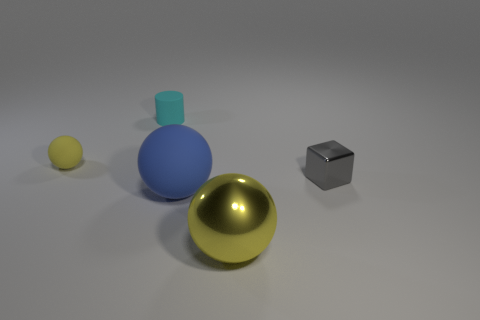What color is the sphere on the left side of the small rubber object right of the yellow object to the left of the large shiny thing?
Provide a short and direct response. Yellow. What number of large yellow metal things are to the right of the large thing behind the big yellow metallic ball?
Your answer should be very brief. 1. How many other objects are there of the same shape as the large matte thing?
Provide a succinct answer. 2. How many things are either large red blocks or balls left of the large yellow metal ball?
Your response must be concise. 2. Is the number of rubber spheres behind the small metal object greater than the number of yellow matte balls that are right of the large metal thing?
Provide a short and direct response. Yes. What is the shape of the shiny object in front of the tiny object that is in front of the yellow sphere that is behind the small gray block?
Your answer should be compact. Sphere. There is a yellow object on the right side of the yellow thing that is behind the large rubber object; what shape is it?
Offer a very short reply. Sphere. Is there a yellow ball made of the same material as the tiny gray block?
Make the answer very short. Yes. The other metallic sphere that is the same color as the small sphere is what size?
Keep it short and to the point. Large. How many red things are either tiny balls or big metal things?
Your response must be concise. 0. 